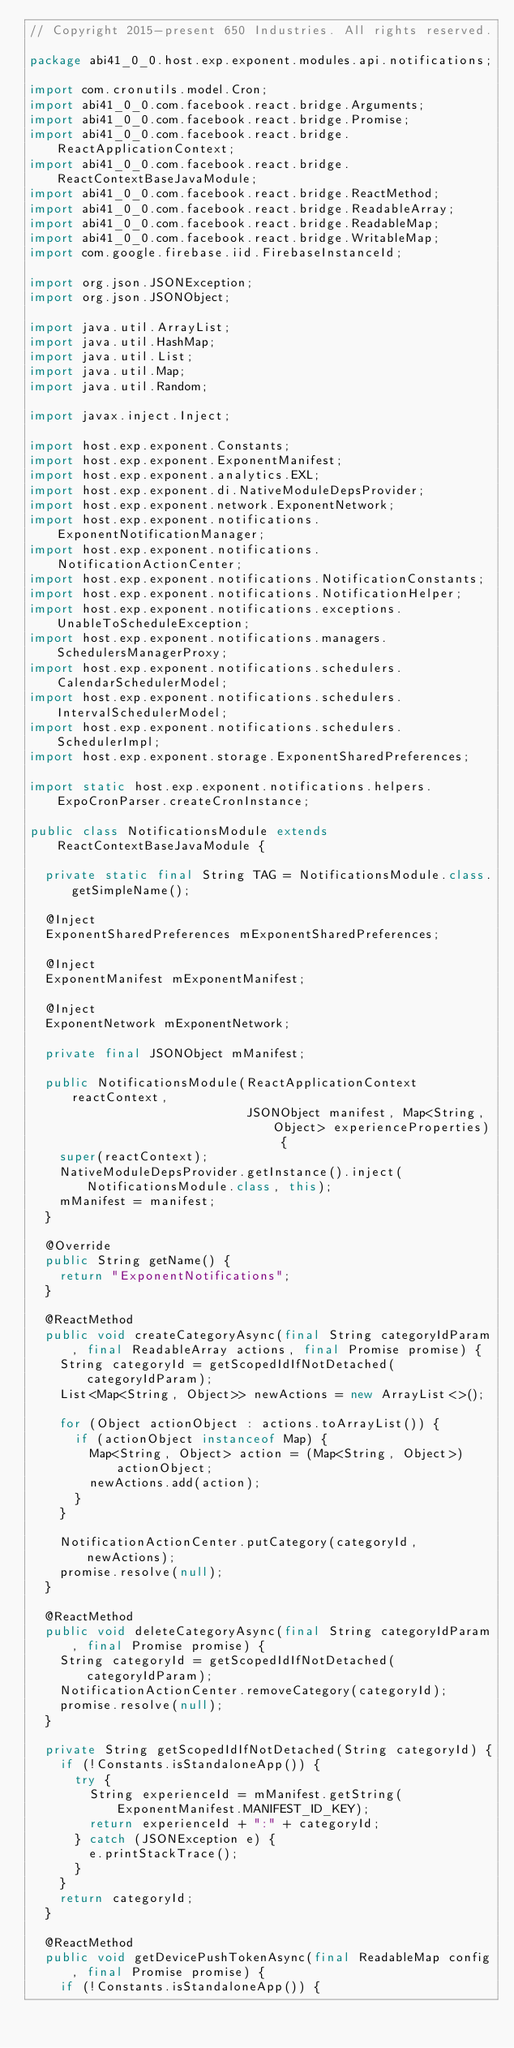<code> <loc_0><loc_0><loc_500><loc_500><_Java_>// Copyright 2015-present 650 Industries. All rights reserved.

package abi41_0_0.host.exp.exponent.modules.api.notifications;

import com.cronutils.model.Cron;
import abi41_0_0.com.facebook.react.bridge.Arguments;
import abi41_0_0.com.facebook.react.bridge.Promise;
import abi41_0_0.com.facebook.react.bridge.ReactApplicationContext;
import abi41_0_0.com.facebook.react.bridge.ReactContextBaseJavaModule;
import abi41_0_0.com.facebook.react.bridge.ReactMethod;
import abi41_0_0.com.facebook.react.bridge.ReadableArray;
import abi41_0_0.com.facebook.react.bridge.ReadableMap;
import abi41_0_0.com.facebook.react.bridge.WritableMap;
import com.google.firebase.iid.FirebaseInstanceId;

import org.json.JSONException;
import org.json.JSONObject;

import java.util.ArrayList;
import java.util.HashMap;
import java.util.List;
import java.util.Map;
import java.util.Random;

import javax.inject.Inject;

import host.exp.exponent.Constants;
import host.exp.exponent.ExponentManifest;
import host.exp.exponent.analytics.EXL;
import host.exp.exponent.di.NativeModuleDepsProvider;
import host.exp.exponent.network.ExponentNetwork;
import host.exp.exponent.notifications.ExponentNotificationManager;
import host.exp.exponent.notifications.NotificationActionCenter;
import host.exp.exponent.notifications.NotificationConstants;
import host.exp.exponent.notifications.NotificationHelper;
import host.exp.exponent.notifications.exceptions.UnableToScheduleException;
import host.exp.exponent.notifications.managers.SchedulersManagerProxy;
import host.exp.exponent.notifications.schedulers.CalendarSchedulerModel;
import host.exp.exponent.notifications.schedulers.IntervalSchedulerModel;
import host.exp.exponent.notifications.schedulers.SchedulerImpl;
import host.exp.exponent.storage.ExponentSharedPreferences;

import static host.exp.exponent.notifications.helpers.ExpoCronParser.createCronInstance;

public class NotificationsModule extends ReactContextBaseJavaModule {

  private static final String TAG = NotificationsModule.class.getSimpleName();

  @Inject
  ExponentSharedPreferences mExponentSharedPreferences;

  @Inject
  ExponentManifest mExponentManifest;

  @Inject
  ExponentNetwork mExponentNetwork;

  private final JSONObject mManifest;

  public NotificationsModule(ReactApplicationContext reactContext,
                             JSONObject manifest, Map<String, Object> experienceProperties) {
    super(reactContext);
    NativeModuleDepsProvider.getInstance().inject(NotificationsModule.class, this);
    mManifest = manifest;
  }

  @Override
  public String getName() {
    return "ExponentNotifications";
  }

  @ReactMethod
  public void createCategoryAsync(final String categoryIdParam, final ReadableArray actions, final Promise promise) {
    String categoryId = getScopedIdIfNotDetached(categoryIdParam);
    List<Map<String, Object>> newActions = new ArrayList<>();

    for (Object actionObject : actions.toArrayList()) {
      if (actionObject instanceof Map) {
        Map<String, Object> action = (Map<String, Object>) actionObject;
        newActions.add(action);
      }
    }

    NotificationActionCenter.putCategory(categoryId, newActions);
    promise.resolve(null);
  }

  @ReactMethod
  public void deleteCategoryAsync(final String categoryIdParam, final Promise promise) {
    String categoryId = getScopedIdIfNotDetached(categoryIdParam);
    NotificationActionCenter.removeCategory(categoryId);
    promise.resolve(null);
  }

  private String getScopedIdIfNotDetached(String categoryId) {
    if (!Constants.isStandaloneApp()) {
      try {
        String experienceId = mManifest.getString(ExponentManifest.MANIFEST_ID_KEY);
        return experienceId + ":" + categoryId;
      } catch (JSONException e) {
        e.printStackTrace();
      }
    }
    return categoryId;
  }

  @ReactMethod
  public void getDevicePushTokenAsync(final ReadableMap config, final Promise promise) {
    if (!Constants.isStandaloneApp()) {</code> 